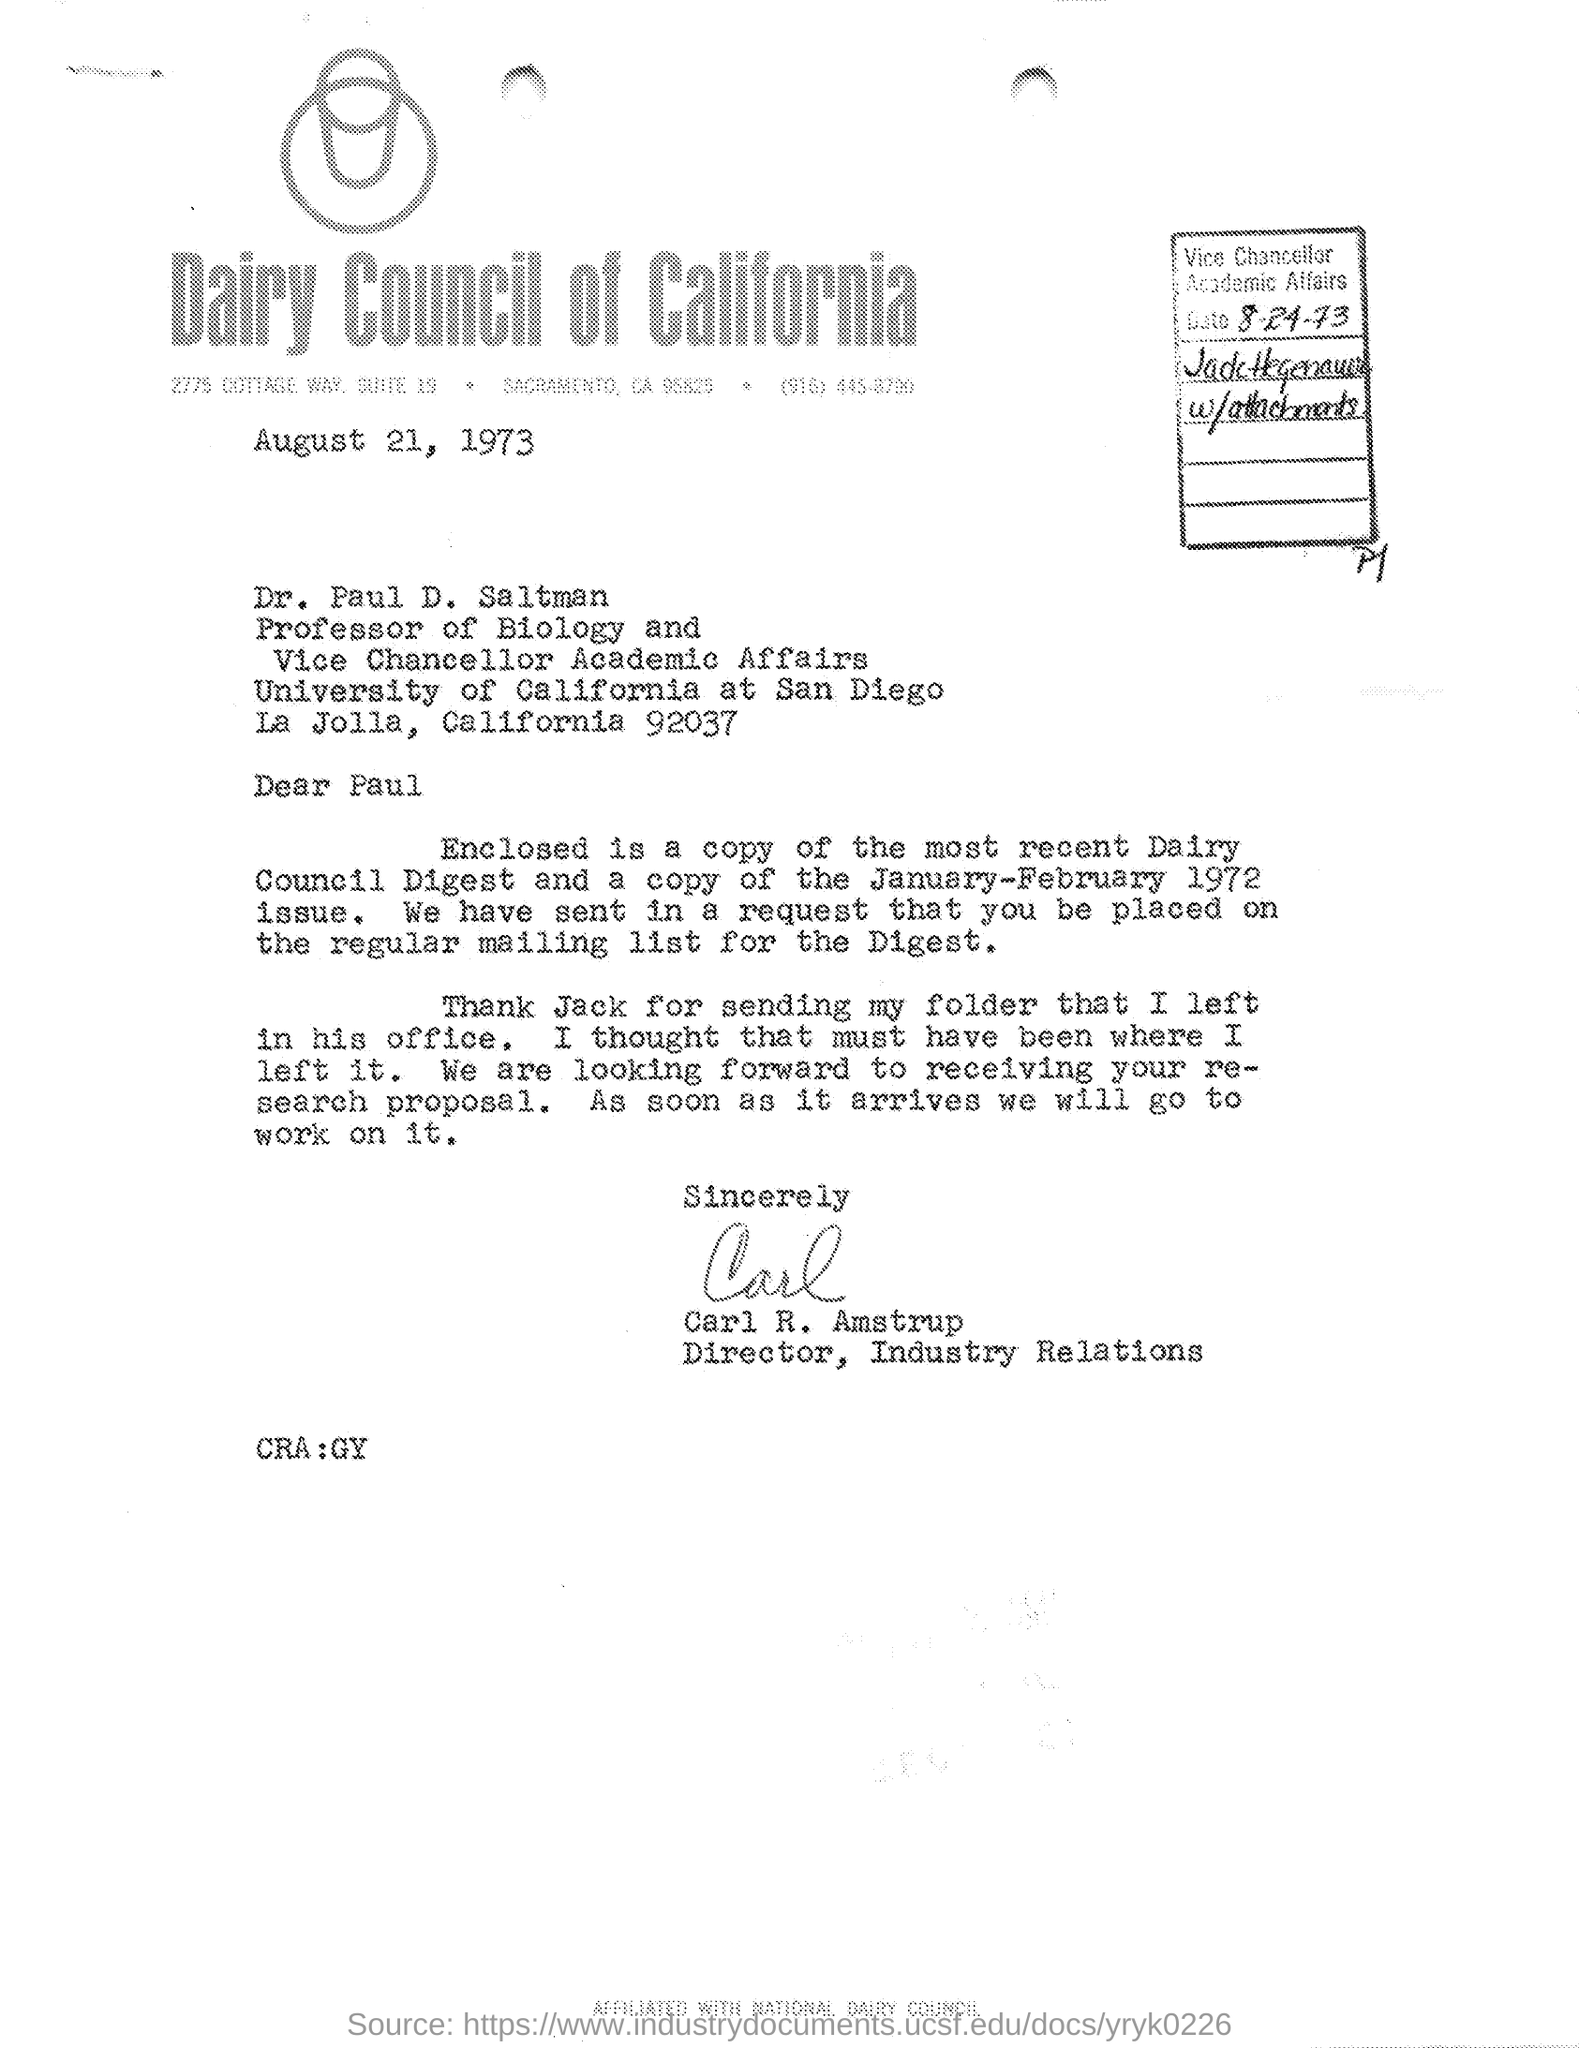On which date this letter was written ?
Provide a succinct answer. August 21, 1973. What is the designation of dr. paul d. salt man ?
Offer a very short reply. Professor of biology and vice chancellor academic affairs. Who's sign was there at the end of the letter ?
Your answer should be very brief. Carl R. Amstrup. What is the designation of carl r. amstrup as mentioned in the given letter ?
Provide a succinct answer. Director, industry relations. 